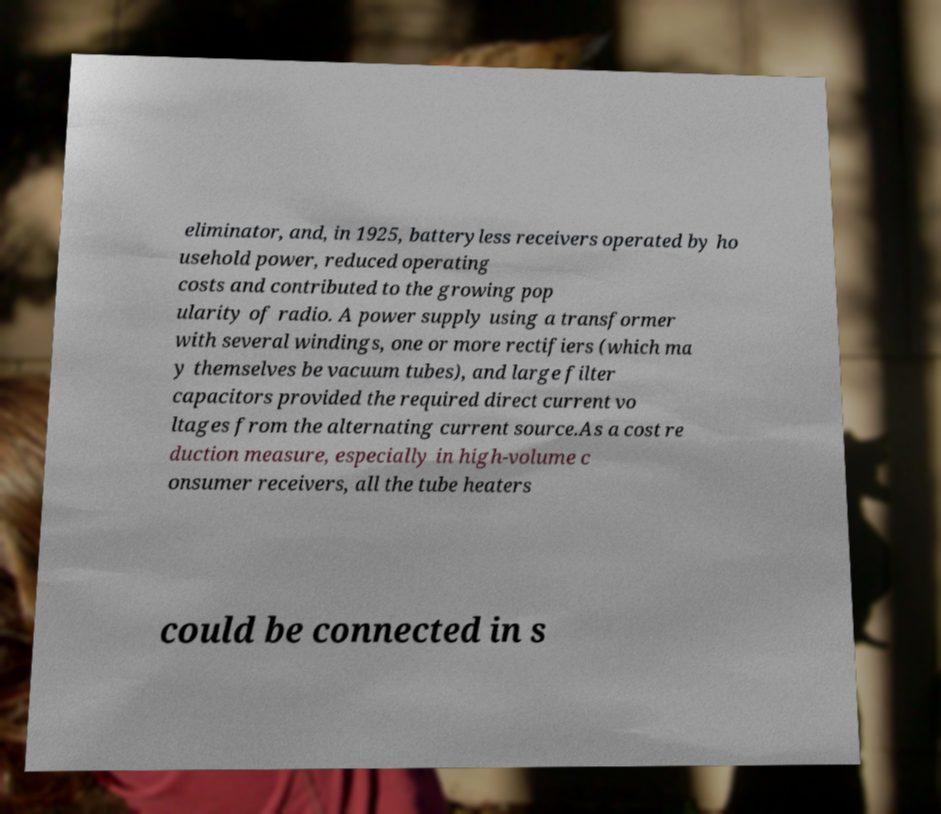What messages or text are displayed in this image? I need them in a readable, typed format. eliminator, and, in 1925, batteryless receivers operated by ho usehold power, reduced operating costs and contributed to the growing pop ularity of radio. A power supply using a transformer with several windings, one or more rectifiers (which ma y themselves be vacuum tubes), and large filter capacitors provided the required direct current vo ltages from the alternating current source.As a cost re duction measure, especially in high-volume c onsumer receivers, all the tube heaters could be connected in s 